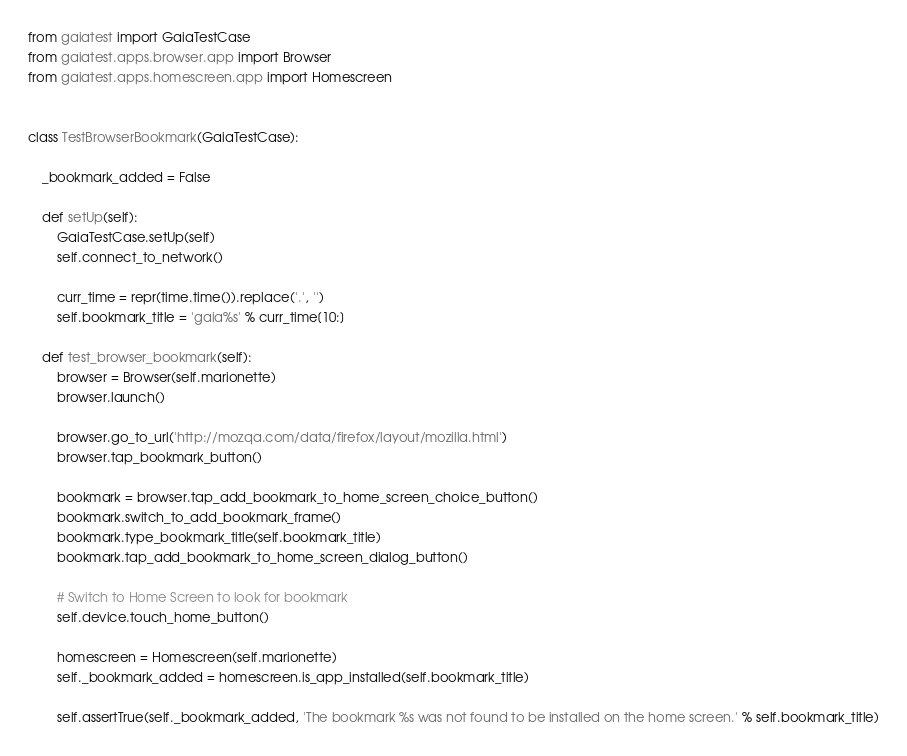Convert code to text. <code><loc_0><loc_0><loc_500><loc_500><_Python_>from gaiatest import GaiaTestCase
from gaiatest.apps.browser.app import Browser
from gaiatest.apps.homescreen.app import Homescreen


class TestBrowserBookmark(GaiaTestCase):

    _bookmark_added = False

    def setUp(self):
        GaiaTestCase.setUp(self)
        self.connect_to_network()

        curr_time = repr(time.time()).replace('.', '')
        self.bookmark_title = 'gaia%s' % curr_time[10:]

    def test_browser_bookmark(self):
        browser = Browser(self.marionette)
        browser.launch()

        browser.go_to_url('http://mozqa.com/data/firefox/layout/mozilla.html')
        browser.tap_bookmark_button()

        bookmark = browser.tap_add_bookmark_to_home_screen_choice_button()
        bookmark.switch_to_add_bookmark_frame()
        bookmark.type_bookmark_title(self.bookmark_title)
        bookmark.tap_add_bookmark_to_home_screen_dialog_button()

        # Switch to Home Screen to look for bookmark
        self.device.touch_home_button()

        homescreen = Homescreen(self.marionette)
        self._bookmark_added = homescreen.is_app_installed(self.bookmark_title)

        self.assertTrue(self._bookmark_added, 'The bookmark %s was not found to be installed on the home screen.' % self.bookmark_title)
</code> 